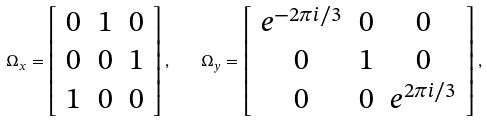<formula> <loc_0><loc_0><loc_500><loc_500>\Omega _ { x } = \left [ \begin{array} { c c c } 0 & 1 & 0 \\ 0 & 0 & 1 \\ 1 & 0 & 0 \\ \end{array} \right ] , \quad \Omega _ { y } = \left [ \begin{array} { c c c } e ^ { - 2 \pi i / 3 } & 0 & 0 \\ 0 & 1 & 0 \\ 0 & 0 & e ^ { 2 \pi i / 3 } \\ \end{array} \right ] ,</formula> 